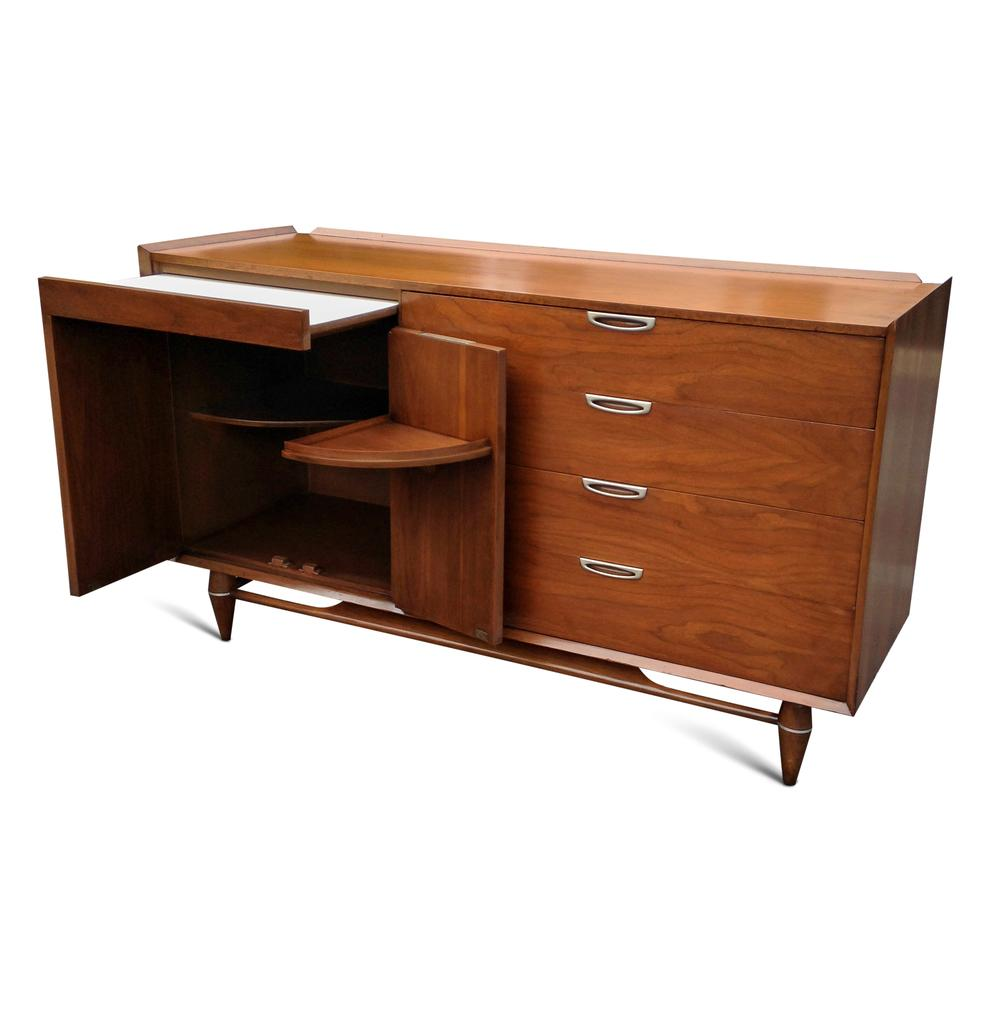What type of table is in the image? There is a wooden table in the image. What feature does the table have? The table has racks. What color is the background of the image? The background of the image is white. How many trains can be seen on the table in the image? There are no trains present in the image; it only features a wooden table with racks. Is there a grandfather sitting at the table in the image? There is no person, including a grandfather, present in the image. 